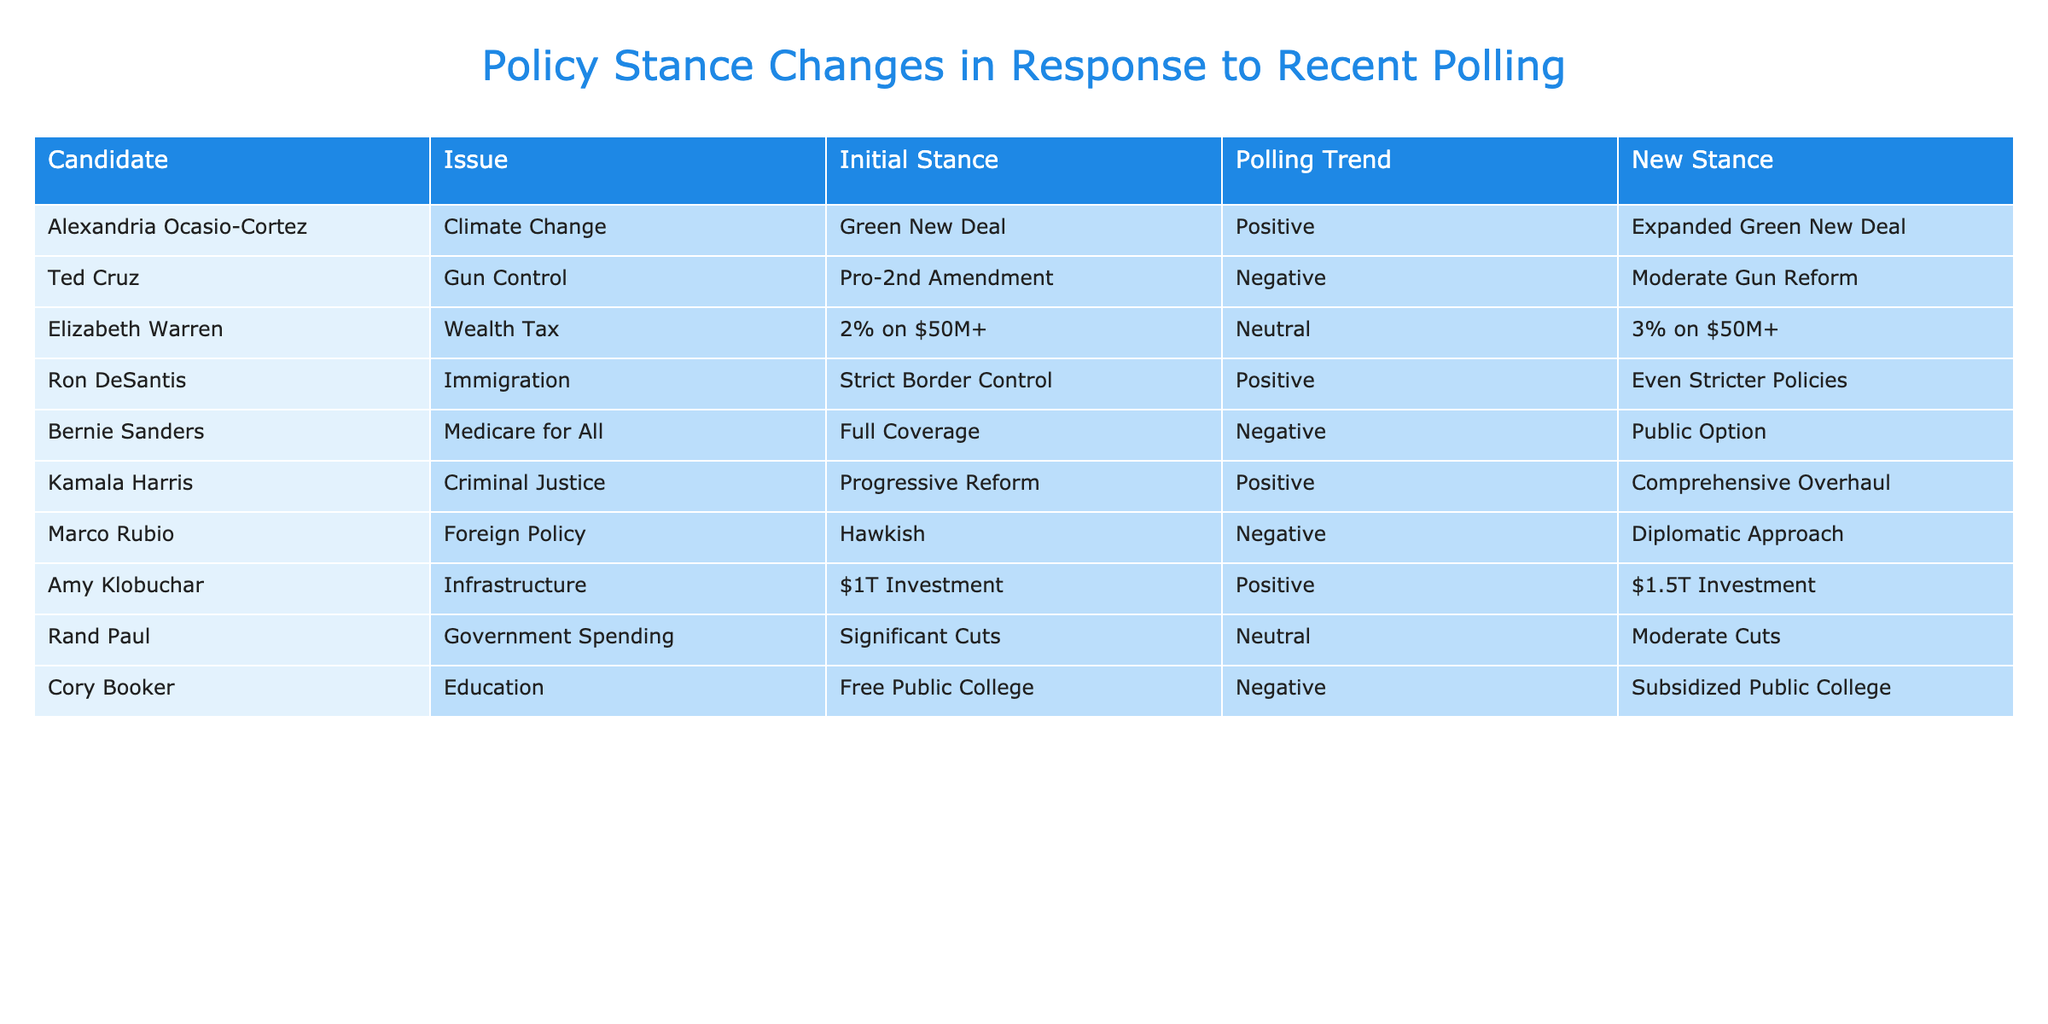What is Alexandria Ocasio-Cortez's new stance on Climate Change? According to the table, Alexandria Ocasio-Cortez initially supported the Green New Deal and, following a positive polling trend, has changed her stance to the Expanded Green New Deal.
Answer: Expanded Green New Deal Which candidate has shifted to a more moderate stance on Gun Control? The table indicates that Ted Cruz, who initially had a Pro-2nd Amendment stance, has changed to a Moderate Gun Reform stance after a negative polling trend.
Answer: Ted Cruz What is the new stance of Bernie Sanders on Medicare for All? The table shows that Bernie Sanders initially supported Medicare for All as Full Coverage, but after a negative polling trend, he has shifted his position to a Public Option.
Answer: Public Option Is it true that Marco Rubio's new Foreign Policy stance became more aggressive? The table indicates that Marco Rubio had a Hawkish stance and has shifted to a Diplomatic Approach, which is less aggressive, confirming that the statement is false.
Answer: False What is the average increase in the proposed investment for Infrastructure across the candidates who changed their stance? Amy Klobuchar's initial stance was $1T, and her new stance is $1.5T, which is an increase of $0.5T. Other candidates did not propose investments in Infrastructure. Thus, the average increase is 0.5T since she's the only one.
Answer: 0.5T Which candidate experienced a negative polling trend but still expanded their policy stance? The table lists Elizabeth Warren, who initially had a 2% Wealth Tax stance, and has increased it to a 3% Wealth Tax despite having a neutral polling trend. This scenario illustrates an expansion in policy, even though polling was neutral.
Answer: Elizabeth Warren How many candidates have a new stance that is more extreme than their original stance? Looking at the table, Ron DeSantis’s shift to Even Stricter Policies and Alexandria Ocasio-Cortez’s shift to Expanded Green New Deal are both more extreme. Counting these gives a total of two candidates.
Answer: 2 What change did Cory Booker make regarding education policy after a negative polling trend? Cory Booker initially supported Free Public College and shifted his stance to Subsidized Public College after a negative trend in polling. This represents a reduction in the level of support for free education.
Answer: Subsidized Public College 